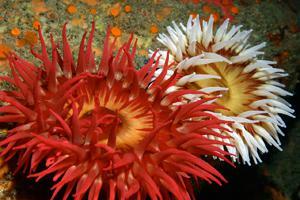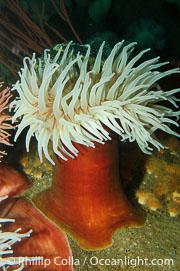The first image is the image on the left, the second image is the image on the right. Given the left and right images, does the statement "In one image, there is at least one fish swimming in or near the sea anemone" hold true? Answer yes or no. No. The first image is the image on the left, the second image is the image on the right. Given the left and right images, does the statement "there are 2 fish swimming near the anenome" hold true? Answer yes or no. No. 